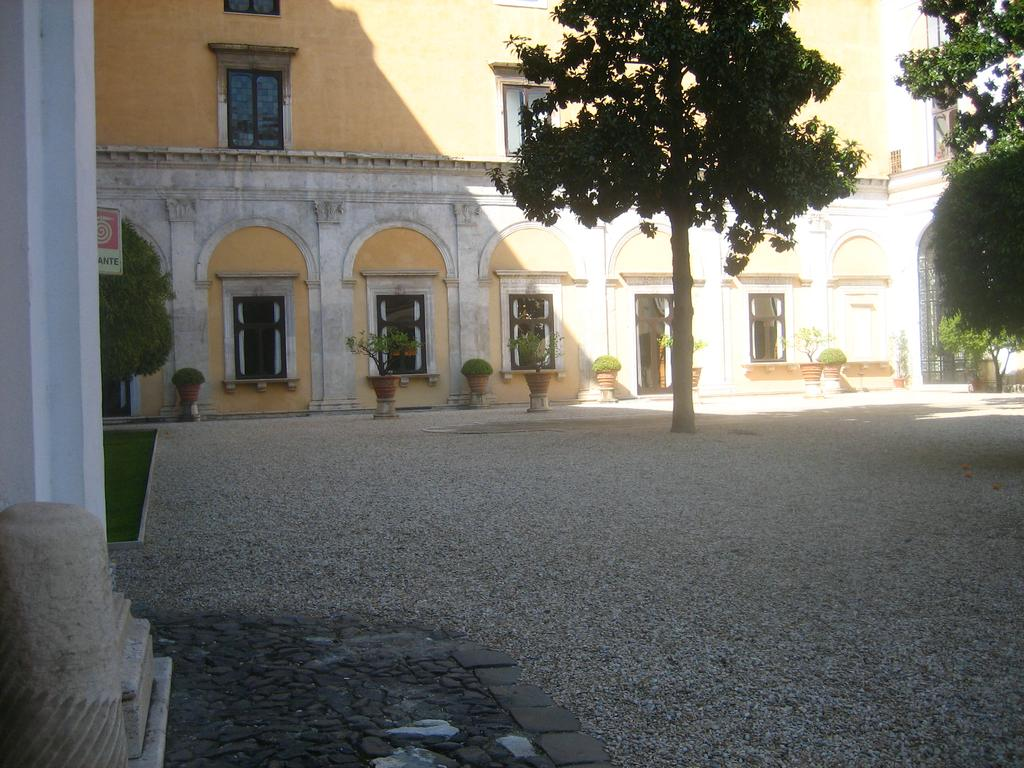What type of structures can be seen in the image? There are buildings in the image. What other natural elements are present in the image? There are trees and plants in pots in the image. What can be found on the ground in the image? Small stones are visible on the ground in the image. Is there any text or signage in the image? Yes, there is a board with text in the image. What type of stew is being cooked in the image? There is no stew present in the image. How many rings can be seen on the trees in the image? There are no rings visible on the trees in the image, as the focus is on the trees' presence rather than their specific features. 